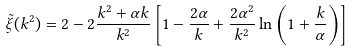Convert formula to latex. <formula><loc_0><loc_0><loc_500><loc_500>\tilde { \xi } ( k ^ { 2 } ) = 2 - 2 \frac { k ^ { 2 } + \alpha k } { k ^ { 2 } } \left [ 1 - \frac { 2 \alpha } { k } + \frac { 2 \alpha ^ { 2 } } { k ^ { 2 } } \ln \left ( 1 + \frac { k } { \alpha } \right ) \right ]</formula> 